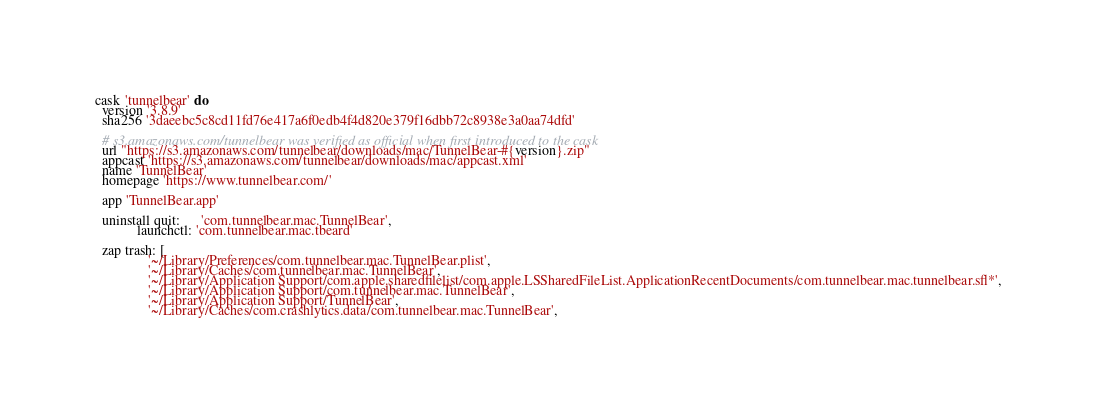Convert code to text. <code><loc_0><loc_0><loc_500><loc_500><_Ruby_>cask 'tunnelbear' do
  version '3.8.9'
  sha256 '3daeebc5c8cd11fd76e417a6f0edb4f4d820e379f16dbb72c8938e3a0aa74dfd'

  # s3.amazonaws.com/tunnelbear was verified as official when first introduced to the cask
  url "https://s3.amazonaws.com/tunnelbear/downloads/mac/TunnelBear-#{version}.zip"
  appcast 'https://s3.amazonaws.com/tunnelbear/downloads/mac/appcast.xml'
  name 'TunnelBear'
  homepage 'https://www.tunnelbear.com/'

  app 'TunnelBear.app'

  uninstall quit:      'com.tunnelbear.mac.TunnelBear',
            launchctl: 'com.tunnelbear.mac.tbeard'

  zap trash: [
               '~/Library/Preferences/com.tunnelbear.mac.TunnelBear.plist',
               '~/Library/Caches/com.tunnelbear.mac.TunnelBear',
               '~/Library/Application Support/com.apple.sharedfilelist/com.apple.LSSharedFileList.ApplicationRecentDocuments/com.tunnelbear.mac.tunnelbear.sfl*',
               '~/Library/Application Support/com.tunnelbear.mac.TunnelBear',
               '~/Library/Application Support/TunnelBear',
               '~/Library/Caches/com.crashlytics.data/com.tunnelbear.mac.TunnelBear',</code> 